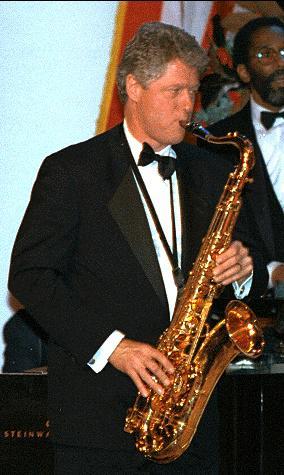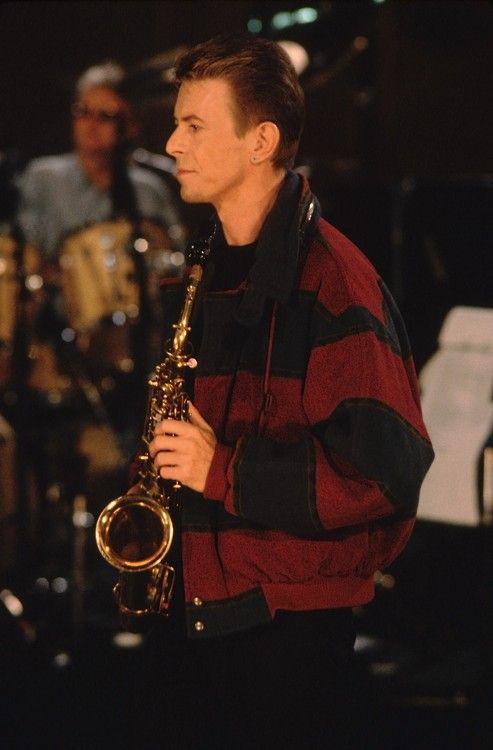The first image is the image on the left, the second image is the image on the right. Examine the images to the left and right. Is the description "An image shows an adult black male with shaved head, playing the saxophone while dressed all in black." accurate? Answer yes or no. No. 